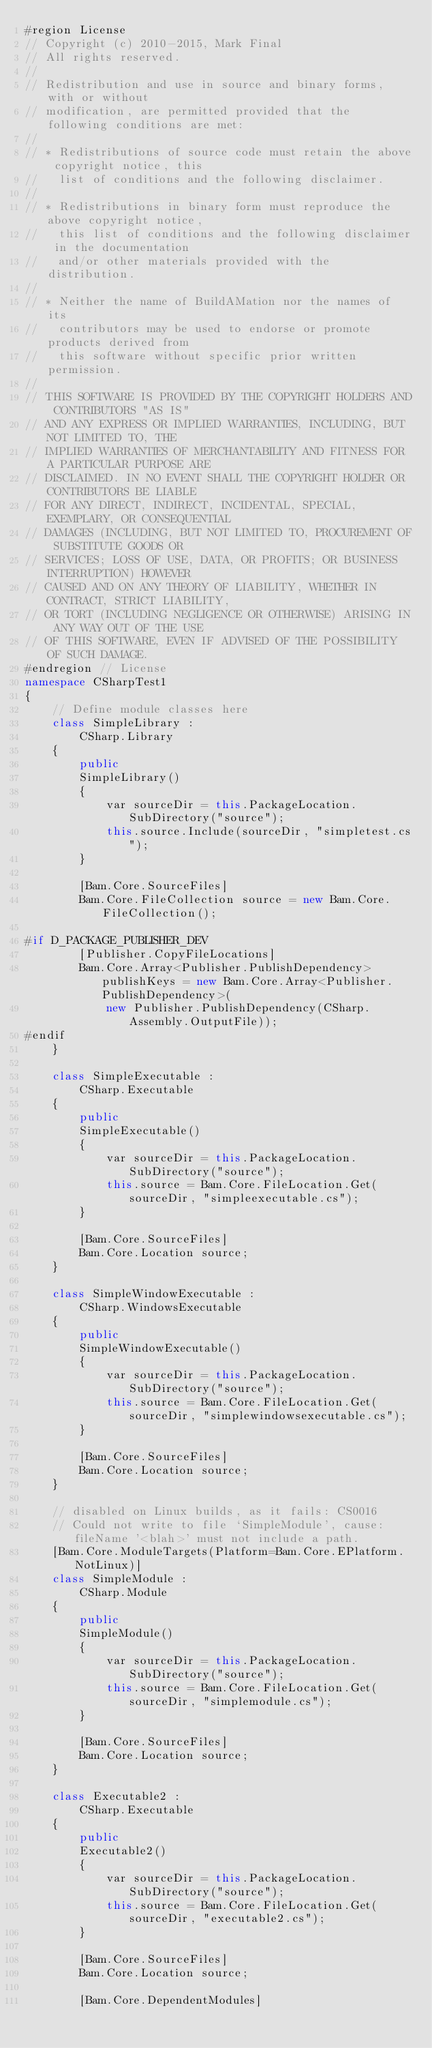<code> <loc_0><loc_0><loc_500><loc_500><_C#_>#region License
// Copyright (c) 2010-2015, Mark Final
// All rights reserved.
//
// Redistribution and use in source and binary forms, with or without
// modification, are permitted provided that the following conditions are met:
//
// * Redistributions of source code must retain the above copyright notice, this
//   list of conditions and the following disclaimer.
//
// * Redistributions in binary form must reproduce the above copyright notice,
//   this list of conditions and the following disclaimer in the documentation
//   and/or other materials provided with the distribution.
//
// * Neither the name of BuildAMation nor the names of its
//   contributors may be used to endorse or promote products derived from
//   this software without specific prior written permission.
//
// THIS SOFTWARE IS PROVIDED BY THE COPYRIGHT HOLDERS AND CONTRIBUTORS "AS IS"
// AND ANY EXPRESS OR IMPLIED WARRANTIES, INCLUDING, BUT NOT LIMITED TO, THE
// IMPLIED WARRANTIES OF MERCHANTABILITY AND FITNESS FOR A PARTICULAR PURPOSE ARE
// DISCLAIMED. IN NO EVENT SHALL THE COPYRIGHT HOLDER OR CONTRIBUTORS BE LIABLE
// FOR ANY DIRECT, INDIRECT, INCIDENTAL, SPECIAL, EXEMPLARY, OR CONSEQUENTIAL
// DAMAGES (INCLUDING, BUT NOT LIMITED TO, PROCUREMENT OF SUBSTITUTE GOODS OR
// SERVICES; LOSS OF USE, DATA, OR PROFITS; OR BUSINESS INTERRUPTION) HOWEVER
// CAUSED AND ON ANY THEORY OF LIABILITY, WHETHER IN CONTRACT, STRICT LIABILITY,
// OR TORT (INCLUDING NEGLIGENCE OR OTHERWISE) ARISING IN ANY WAY OUT OF THE USE
// OF THIS SOFTWARE, EVEN IF ADVISED OF THE POSSIBILITY OF SUCH DAMAGE.
#endregion // License
namespace CSharpTest1
{
    // Define module classes here
    class SimpleLibrary :
        CSharp.Library
    {
        public
        SimpleLibrary()
        {
            var sourceDir = this.PackageLocation.SubDirectory("source");
            this.source.Include(sourceDir, "simpletest.cs");
        }

        [Bam.Core.SourceFiles]
        Bam.Core.FileCollection source = new Bam.Core.FileCollection();

#if D_PACKAGE_PUBLISHER_DEV
        [Publisher.CopyFileLocations]
        Bam.Core.Array<Publisher.PublishDependency> publishKeys = new Bam.Core.Array<Publisher.PublishDependency>(
            new Publisher.PublishDependency(CSharp.Assembly.OutputFile));
#endif
    }

    class SimpleExecutable :
        CSharp.Executable
    {
        public
        SimpleExecutable()
        {
            var sourceDir = this.PackageLocation.SubDirectory("source");
            this.source = Bam.Core.FileLocation.Get(sourceDir, "simpleexecutable.cs");
        }

        [Bam.Core.SourceFiles]
        Bam.Core.Location source;
    }

    class SimpleWindowExecutable :
        CSharp.WindowsExecutable
    {
        public
        SimpleWindowExecutable()
        {
            var sourceDir = this.PackageLocation.SubDirectory("source");
            this.source = Bam.Core.FileLocation.Get(sourceDir, "simplewindowsexecutable.cs");
        }

        [Bam.Core.SourceFiles]
        Bam.Core.Location source;
    }

    // disabled on Linux builds, as it fails: CS0016
    // Could not write to file `SimpleModule', cause: fileName '<blah>' must not include a path.
    [Bam.Core.ModuleTargets(Platform=Bam.Core.EPlatform.NotLinux)]
    class SimpleModule :
        CSharp.Module
    {
        public
        SimpleModule()
        {
            var sourceDir = this.PackageLocation.SubDirectory("source");
            this.source = Bam.Core.FileLocation.Get(sourceDir, "simplemodule.cs");
        }

        [Bam.Core.SourceFiles]
        Bam.Core.Location source;
    }

    class Executable2 :
        CSharp.Executable
    {
        public
        Executable2()
        {
            var sourceDir = this.PackageLocation.SubDirectory("source");
            this.source = Bam.Core.FileLocation.Get(sourceDir, "executable2.cs");
        }

        [Bam.Core.SourceFiles]
        Bam.Core.Location source;

        [Bam.Core.DependentModules]</code> 